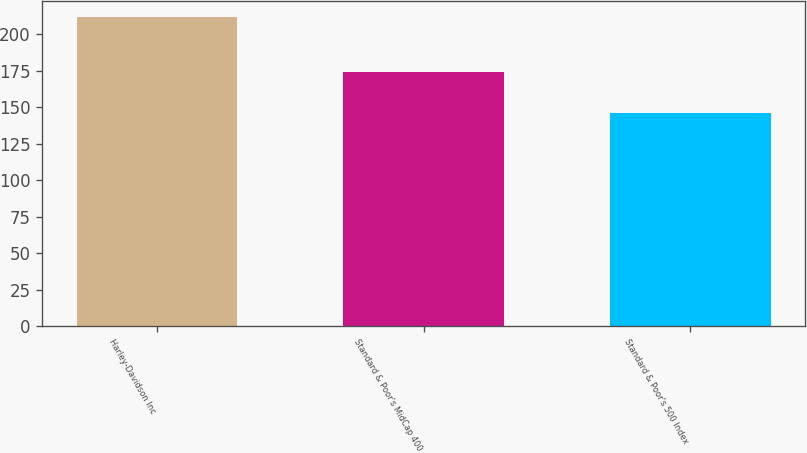<chart> <loc_0><loc_0><loc_500><loc_500><bar_chart><fcel>Harley-Davidson Inc<fcel>Standard & Poor's MidCap 400<fcel>Standard & Poor's 500 Index<nl><fcel>212<fcel>174<fcel>146<nl></chart> 